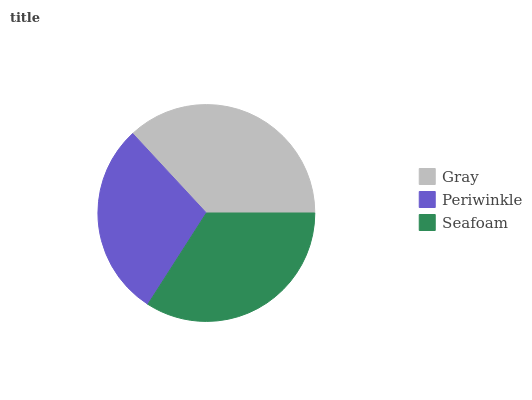Is Periwinkle the minimum?
Answer yes or no. Yes. Is Gray the maximum?
Answer yes or no. Yes. Is Seafoam the minimum?
Answer yes or no. No. Is Seafoam the maximum?
Answer yes or no. No. Is Seafoam greater than Periwinkle?
Answer yes or no. Yes. Is Periwinkle less than Seafoam?
Answer yes or no. Yes. Is Periwinkle greater than Seafoam?
Answer yes or no. No. Is Seafoam less than Periwinkle?
Answer yes or no. No. Is Seafoam the high median?
Answer yes or no. Yes. Is Seafoam the low median?
Answer yes or no. Yes. Is Periwinkle the high median?
Answer yes or no. No. Is Periwinkle the low median?
Answer yes or no. No. 